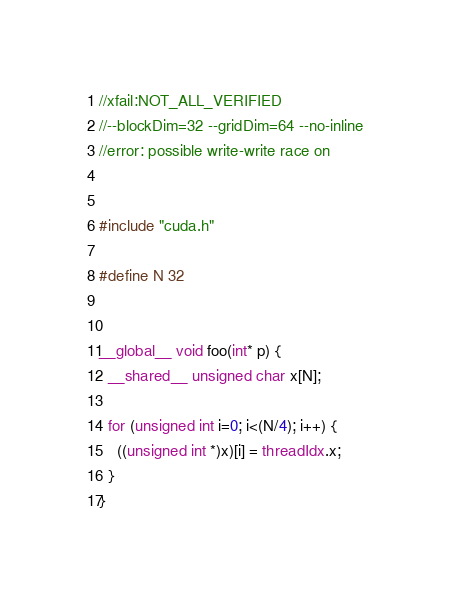<code> <loc_0><loc_0><loc_500><loc_500><_Cuda_>//xfail:NOT_ALL_VERIFIED
//--blockDim=32 --gridDim=64 --no-inline
//error: possible write-write race on


#include "cuda.h"

#define N 32


__global__ void foo(int* p) {
  __shared__ unsigned char x[N];

  for (unsigned int i=0; i<(N/4); i++) {
    ((unsigned int *)x)[i] = threadIdx.x;
  }
}
</code> 